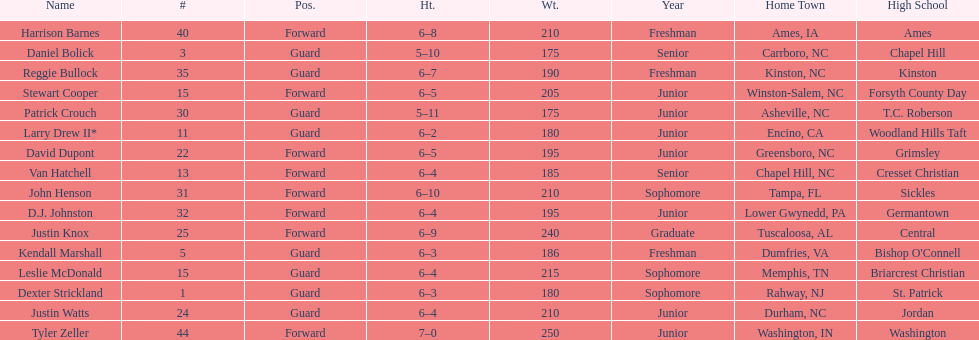Names of athletes who were precisely 6 feet, 4 inches tall, but did not weigh more than 200 pounds. Van Hatchell, D.J. Johnston. 